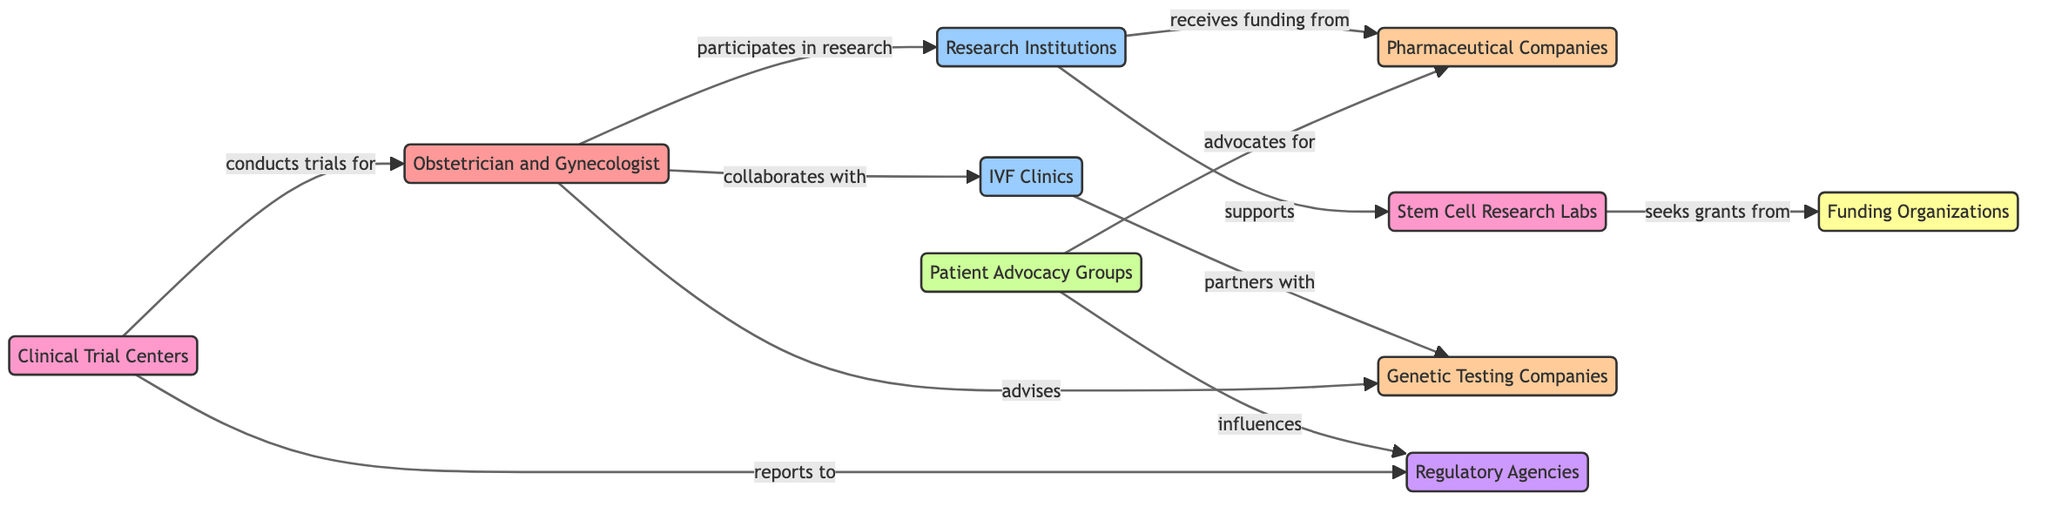What is the total number of nodes in the diagram? There are ten nodes in the diagram, as listed under the "nodes" section of the data provided.
Answer: 10 Which organization advocates for pharmaceutical companies? The "Patient Advocacy Groups" node connects to the "Pharmaceutical Companies" node with the relationship indicating they advocate for them.
Answer: Patient Advocacy Groups How many edges are connected to the "Research Institutions" node? The diagram shows four edges connected to the "Research Institutions" node, linking it to "Obstetrician and Gynecologist," "Pharmaceutical Companies," "Stem Cell Research Labs," and indirectly through interactions.
Answer: 4 Which entity does the "Clinical Trial Centers" conduct trials for? The relationship shows that "Clinical Trial Centers" conducts trials for the "Obstetrician and Gynecologist" node.
Answer: Obstetrician and Gynecologist What type of connection exists between "IVF Clinics" and "Genetic Testing Companies"? The edge between these two nodes indicates a partnership relationship, as shown in the diagram.
Answer: partners with Which node influences the "Regulatory Agencies"? The "Patient Advocacy Groups" node is shown to influence the "Regulatory Agencies" node in the diagram.
Answer: Patient Advocacy Groups Which two types of entities are connected to the "Stem Cell Research Labs"? The "Stem Cell Research Labs" are connected to "Research Institutions" (supporting) and "Funding Organizations" (seeking grants).
Answer: Research Institutions and Funding Organizations How many different organization types are represented in the diagram? There are six distinct types of entities represented: specialist, institution, industry, organization, research, government, and finance, totaling to six types.
Answer: 6 What is the main role of the "Funding Organizations" in the network? The "Funding Organizations" mainly provide grants to "Stem Cell Research Labs" as indicated by the relationship in the diagram.
Answer: seeks grants from 